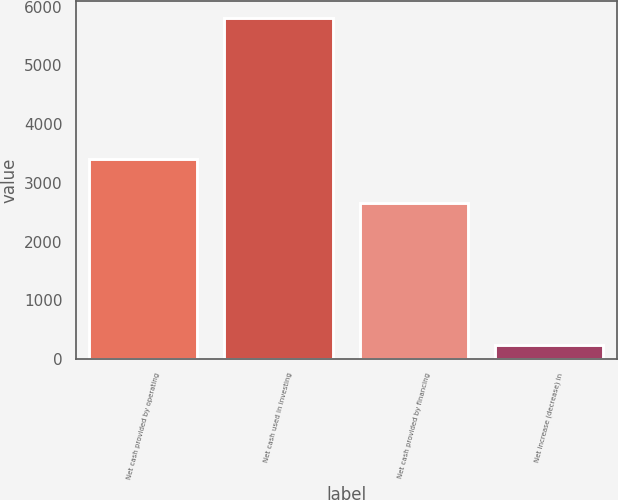Convert chart. <chart><loc_0><loc_0><loc_500><loc_500><bar_chart><fcel>Net cash provided by operating<fcel>Net cash used in investing<fcel>Net cash provided by financing<fcel>Net increase (decrease) in<nl><fcel>3403<fcel>5808<fcel>2650<fcel>245<nl></chart> 